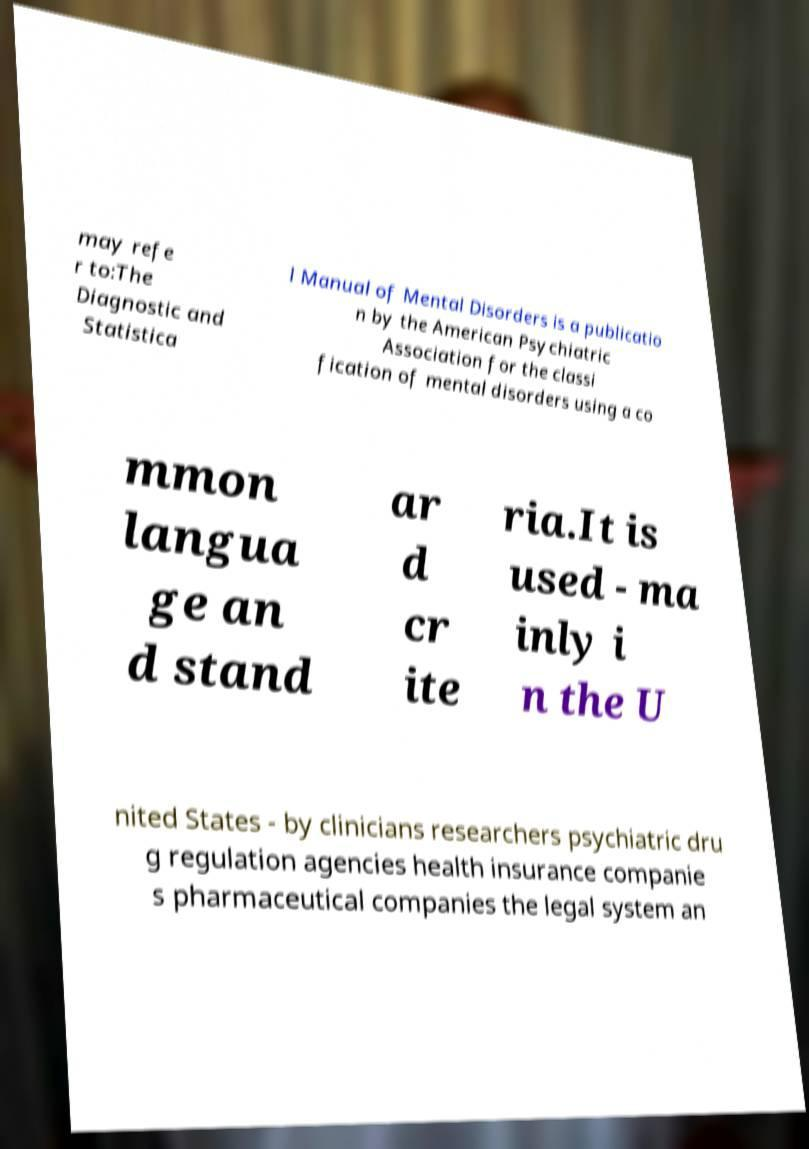Could you extract and type out the text from this image? may refe r to:The Diagnostic and Statistica l Manual of Mental Disorders is a publicatio n by the American Psychiatric Association for the classi fication of mental disorders using a co mmon langua ge an d stand ar d cr ite ria.It is used - ma inly i n the U nited States - by clinicians researchers psychiatric dru g regulation agencies health insurance companie s pharmaceutical companies the legal system an 